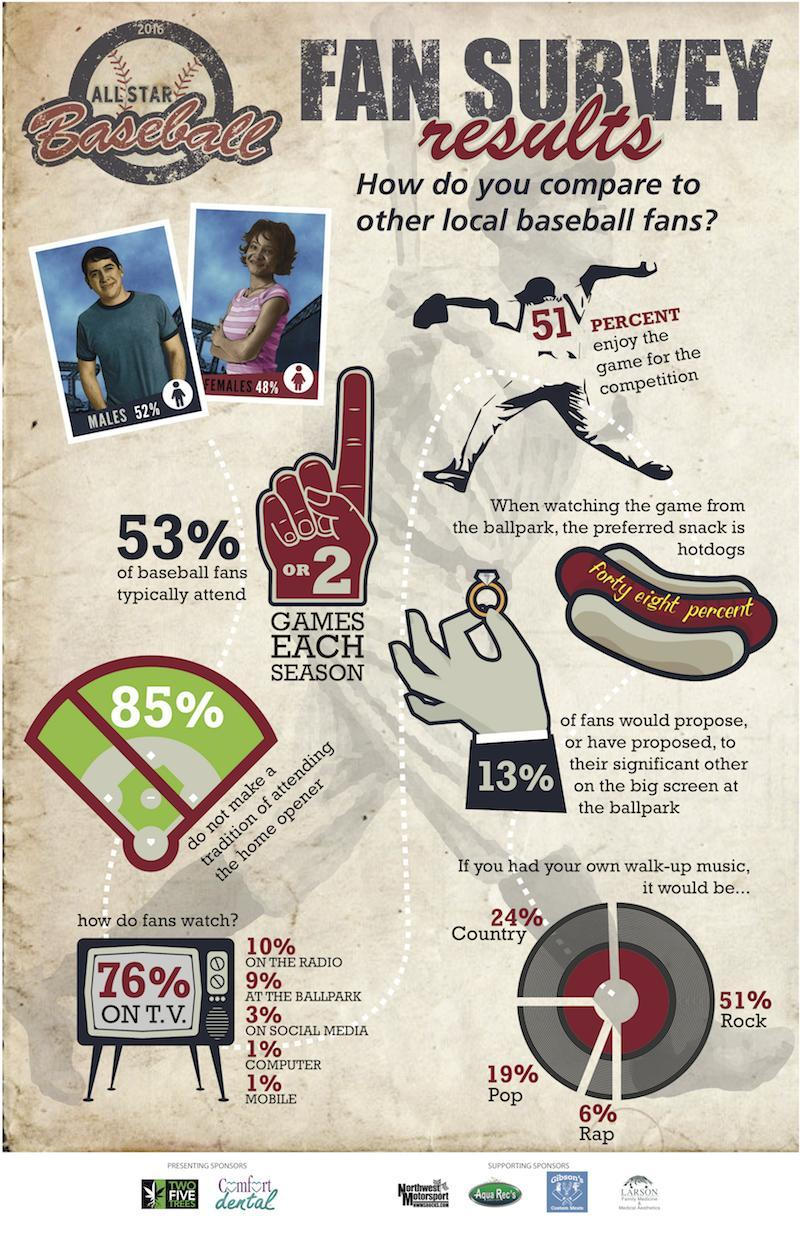What percentage of fans are watching baseball not on social media?
Answer the question with a short phrase. 97% What percentage of fans are watching baseball not on the mobile? 99% What percentage of fans are watching baseball not on the T.V? 24% What percentage of fans are watching baseball not at the ballpark? 91% What percentage of fans are watching baseball not on the radio? 90% What percentage enjoy the game, not for the competition? 49% What percentage of fans are watching baseball not on computer? 99% 